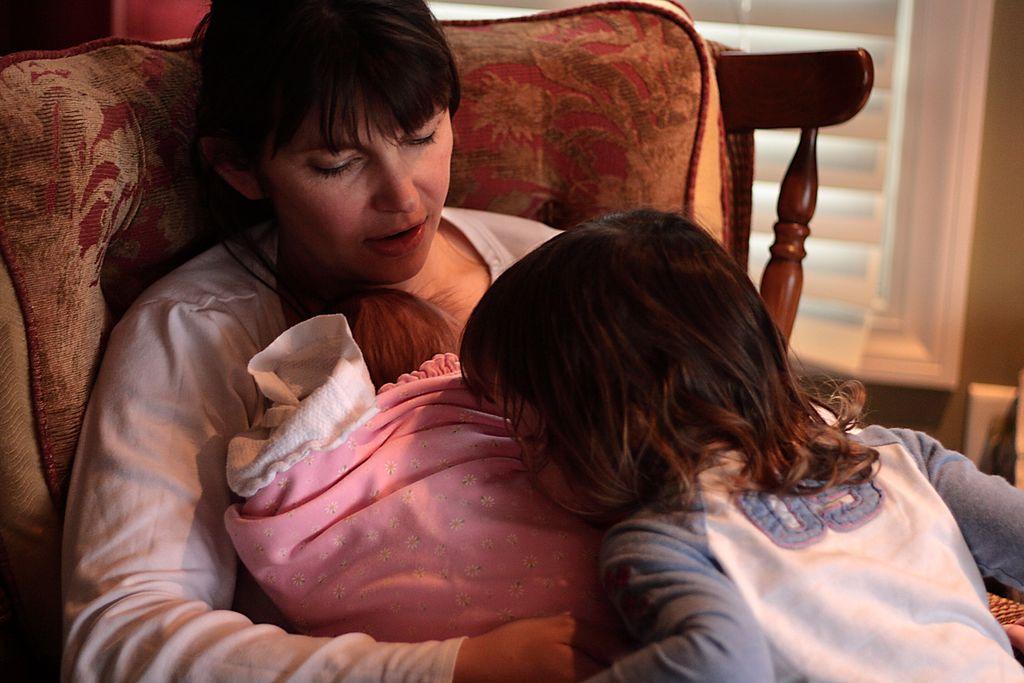How would you summarize this image in a sentence or two? Here we can see a woman is sitting and holding a baby in her lap, and in front here a child is standing and kissing. 